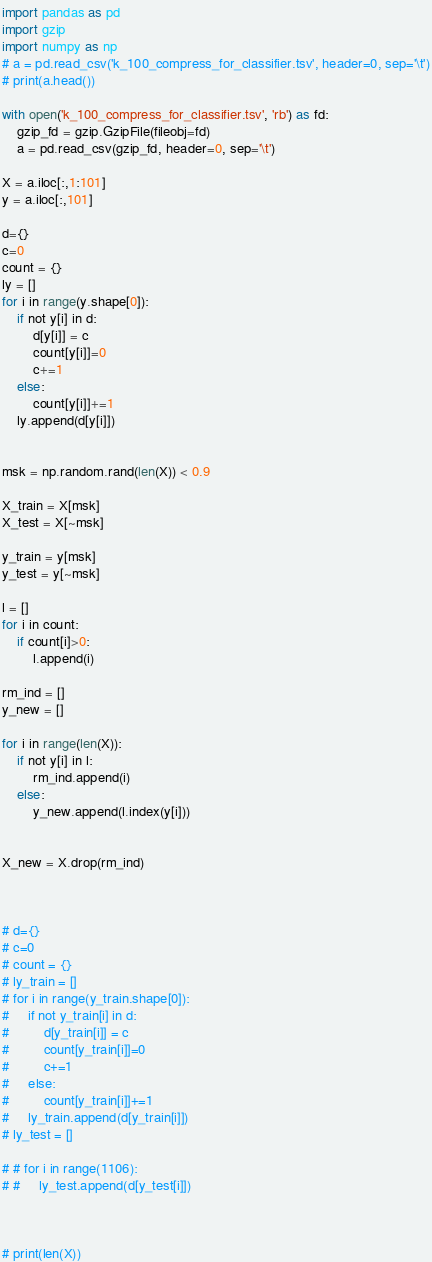<code> <loc_0><loc_0><loc_500><loc_500><_Python_>import pandas as pd
import gzip
import numpy as np
# a = pd.read_csv('k_100_compress_for_classifier.tsv', header=0, sep='\t')
# print(a.head())

with open('k_100_compress_for_classifier.tsv', 'rb') as fd:
    gzip_fd = gzip.GzipFile(fileobj=fd)
    a = pd.read_csv(gzip_fd, header=0, sep='\t')

X = a.iloc[:,1:101]
y = a.iloc[:,101]

d={}
c=0
count = {}
ly = []
for i in range(y.shape[0]):
    if not y[i] in d:
        d[y[i]] = c
        count[y[i]]=0
        c+=1
    else:
        count[y[i]]+=1
    ly.append(d[y[i]])


msk = np.random.rand(len(X)) < 0.9

X_train = X[msk]
X_test = X[~msk]

y_train = y[msk]
y_test = y[~msk]

l = []
for i in count:
    if count[i]>0:
        l.append(i)

rm_ind = []
y_new = []

for i in range(len(X)):
    if not y[i] in l:
        rm_ind.append(i)
    else:
        y_new.append(l.index(y[i]))


X_new = X.drop(rm_ind)



# d={}
# c=0
# count = {}
# ly_train = []
# for i in range(y_train.shape[0]):
#     if not y_train[i] in d:
#         d[y_train[i]] = c
#         count[y_train[i]]=0
#         c+=1
#     else:
#         count[y_train[i]]+=1
#     ly_train.append(d[y_train[i]])
# ly_test = []

# # for i in range(1106):
# #     ly_test.append(d[y_test[i]])



# print(len(X))

</code> 